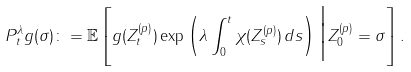<formula> <loc_0><loc_0><loc_500><loc_500>P _ { t } ^ { \lambda } g ( \sigma ) \colon = \mathbb { E } \left [ g ( Z _ { t } ^ { ( p ) } ) \exp \left ( \lambda \int _ { 0 } ^ { t } \chi ( Z _ { s } ^ { ( p ) } ) \, d s \right ) \Big | Z _ { 0 } ^ { ( p ) } = \sigma \right ] .</formula> 